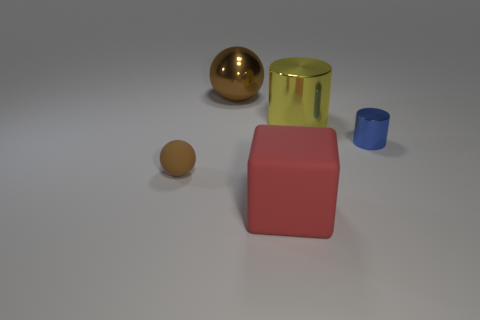How many large things are either blue shiny cylinders or cyan metallic spheres?
Ensure brevity in your answer.  0. What color is the rubber block that is the same size as the brown metallic object?
Offer a terse response. Red. What number of other objects are there of the same shape as the yellow metal thing?
Offer a terse response. 1. Is there a tiny brown cube made of the same material as the small brown thing?
Your response must be concise. No. Are the brown sphere that is right of the small rubber object and the small object that is right of the big brown metallic sphere made of the same material?
Make the answer very short. Yes. How many small brown rubber objects are there?
Your answer should be compact. 1. What is the shape of the tiny object to the left of the large sphere?
Your response must be concise. Sphere. How many other objects are the same size as the blue shiny object?
Offer a terse response. 1. There is a metallic thing behind the big yellow cylinder; does it have the same shape as the large thing that is to the right of the rubber cube?
Your response must be concise. No. What number of spheres are in front of the blue cylinder?
Ensure brevity in your answer.  1. 